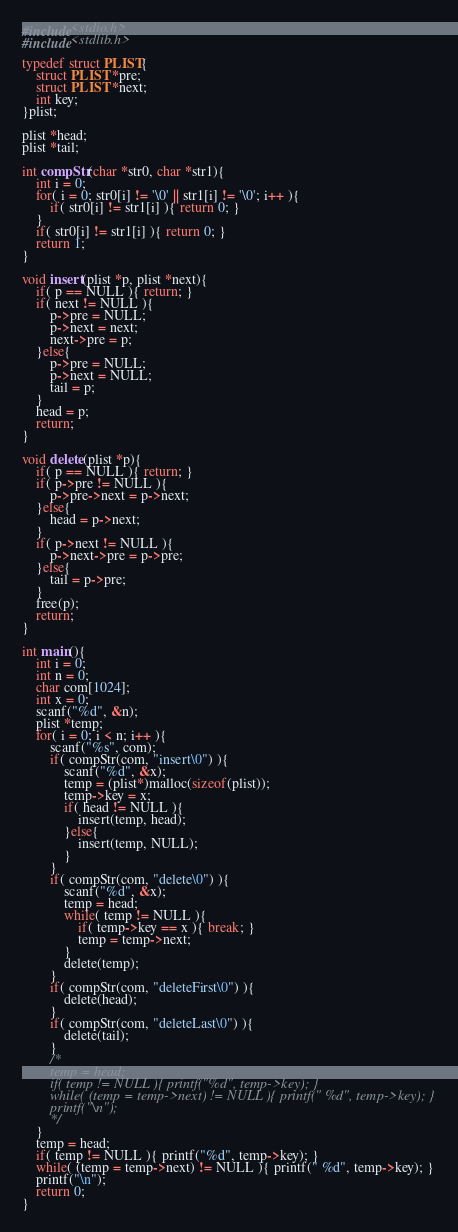<code> <loc_0><loc_0><loc_500><loc_500><_C_>#include<stdio.h>
#include<stdlib.h>

typedef struct PLIST{
	struct PLIST *pre;
	struct PLIST *next;
	int key;
}plist;

plist *head;
plist *tail;

int compStr(char *str0, char *str1){
	int i = 0;
	for( i = 0; str0[i] != '\0' || str1[i] != '\0'; i++ ){
		if( str0[i] != str1[i] ){ return 0; }
	}
	if( str0[i] != str1[i] ){ return 0; }
	return 1;
}

void insert(plist *p, plist *next){
	if( p == NULL ){ return; }
	if( next != NULL ){
		p->pre = NULL;
		p->next = next;
		next->pre = p;
	}else{
		p->pre = NULL;
		p->next = NULL;
		tail = p;
	}
	head = p;
	return;
}

void delete(plist *p){
	if( p == NULL ){ return; }
	if( p->pre != NULL ){
		p->pre->next = p->next;
	}else{
		head = p->next;
	}
	if( p->next != NULL ){
		p->next->pre = p->pre;
	}else{
		tail = p->pre;
	}
	free(p);
	return;
}

int main(){
	int i = 0;
	int n = 0;
	char com[1024];
	int x = 0;
	scanf("%d", &n);
	plist *temp;
	for( i = 0; i < n; i++ ){
		scanf("%s", com);
		if( compStr(com, "insert\0") ){
			scanf("%d", &x);
			temp = (plist*)malloc(sizeof(plist));
			temp->key = x;
			if( head != NULL ){
				insert(temp, head);
			}else{
				insert(temp, NULL);
			}
		}
		if( compStr(com, "delete\0") ){
			scanf("%d", &x);
			temp = head;
			while( temp != NULL ){
				if( temp->key == x ){ break; }
				temp = temp->next;
			}
			delete(temp);
		}
		if( compStr(com, "deleteFirst\0") ){
			delete(head);
		}
		if( compStr(com, "deleteLast\0") ){
			delete(tail);
		}
		/*
		temp = head;
		if( temp != NULL ){ printf("%d", temp->key); }
		while( (temp = temp->next) != NULL ){ printf(" %d", temp->key); }
		printf("\n");
		*/
	}
	temp = head;
	if( temp != NULL ){ printf("%d", temp->key); }
	while( (temp = temp->next) != NULL ){ printf(" %d", temp->key); }
	printf("\n");
	return 0;
}</code> 